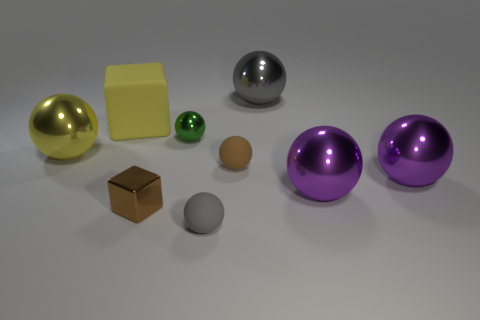What is the material of the block behind the green shiny object?
Your response must be concise. Rubber. What is the size of the gray shiny object?
Your answer should be compact. Large. There is a rubber object behind the small green sphere; does it have the same size as the gray object in front of the metallic cube?
Your answer should be very brief. No. The green metal thing that is the same shape as the yellow metallic thing is what size?
Provide a succinct answer. Small. There is a gray metal thing; is it the same size as the green metallic sphere that is on the right side of the large cube?
Make the answer very short. No. There is a gray object that is in front of the matte block; are there any shiny cubes behind it?
Offer a terse response. Yes. The tiny metallic thing that is behind the brown metallic object has what shape?
Make the answer very short. Sphere. There is a large sphere that is the same color as the large cube; what material is it?
Offer a very short reply. Metal. What is the color of the small matte ball that is behind the tiny brown thing on the left side of the gray matte ball?
Give a very brief answer. Brown. Do the green object and the yellow shiny thing have the same size?
Offer a very short reply. No. 